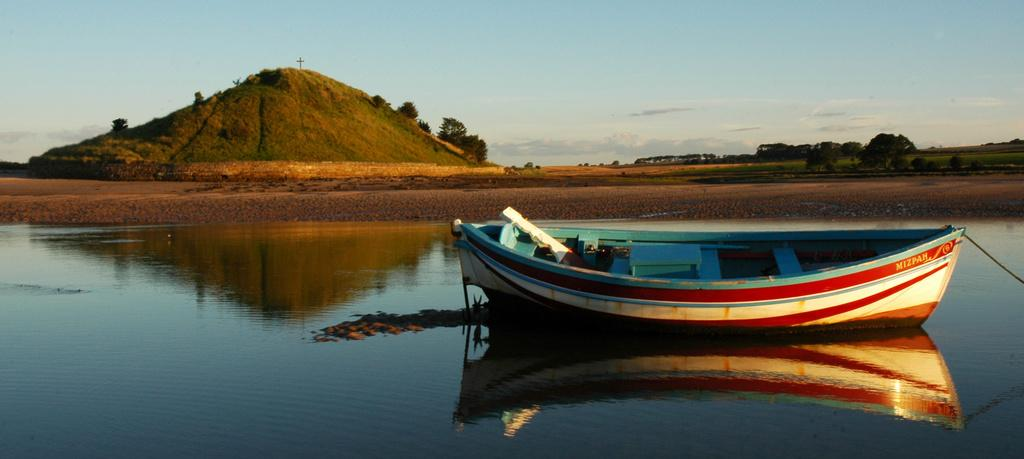What is the main subject of the image? The main subject of the image is a boat. Where is the boat located? The boat is on the water. What can be seen in the background of the image? There are hills and a group of trees visible behind the water. What is visible at the top of the image? The sky is visible at the top of the image. How much blood is visible on the boat in the image? There is no blood visible on the boat in the image. What type of debt is being discussed in the image? There is no discussion of debt in the image; it features a boat on the water with hills, trees, and sky in the background. 